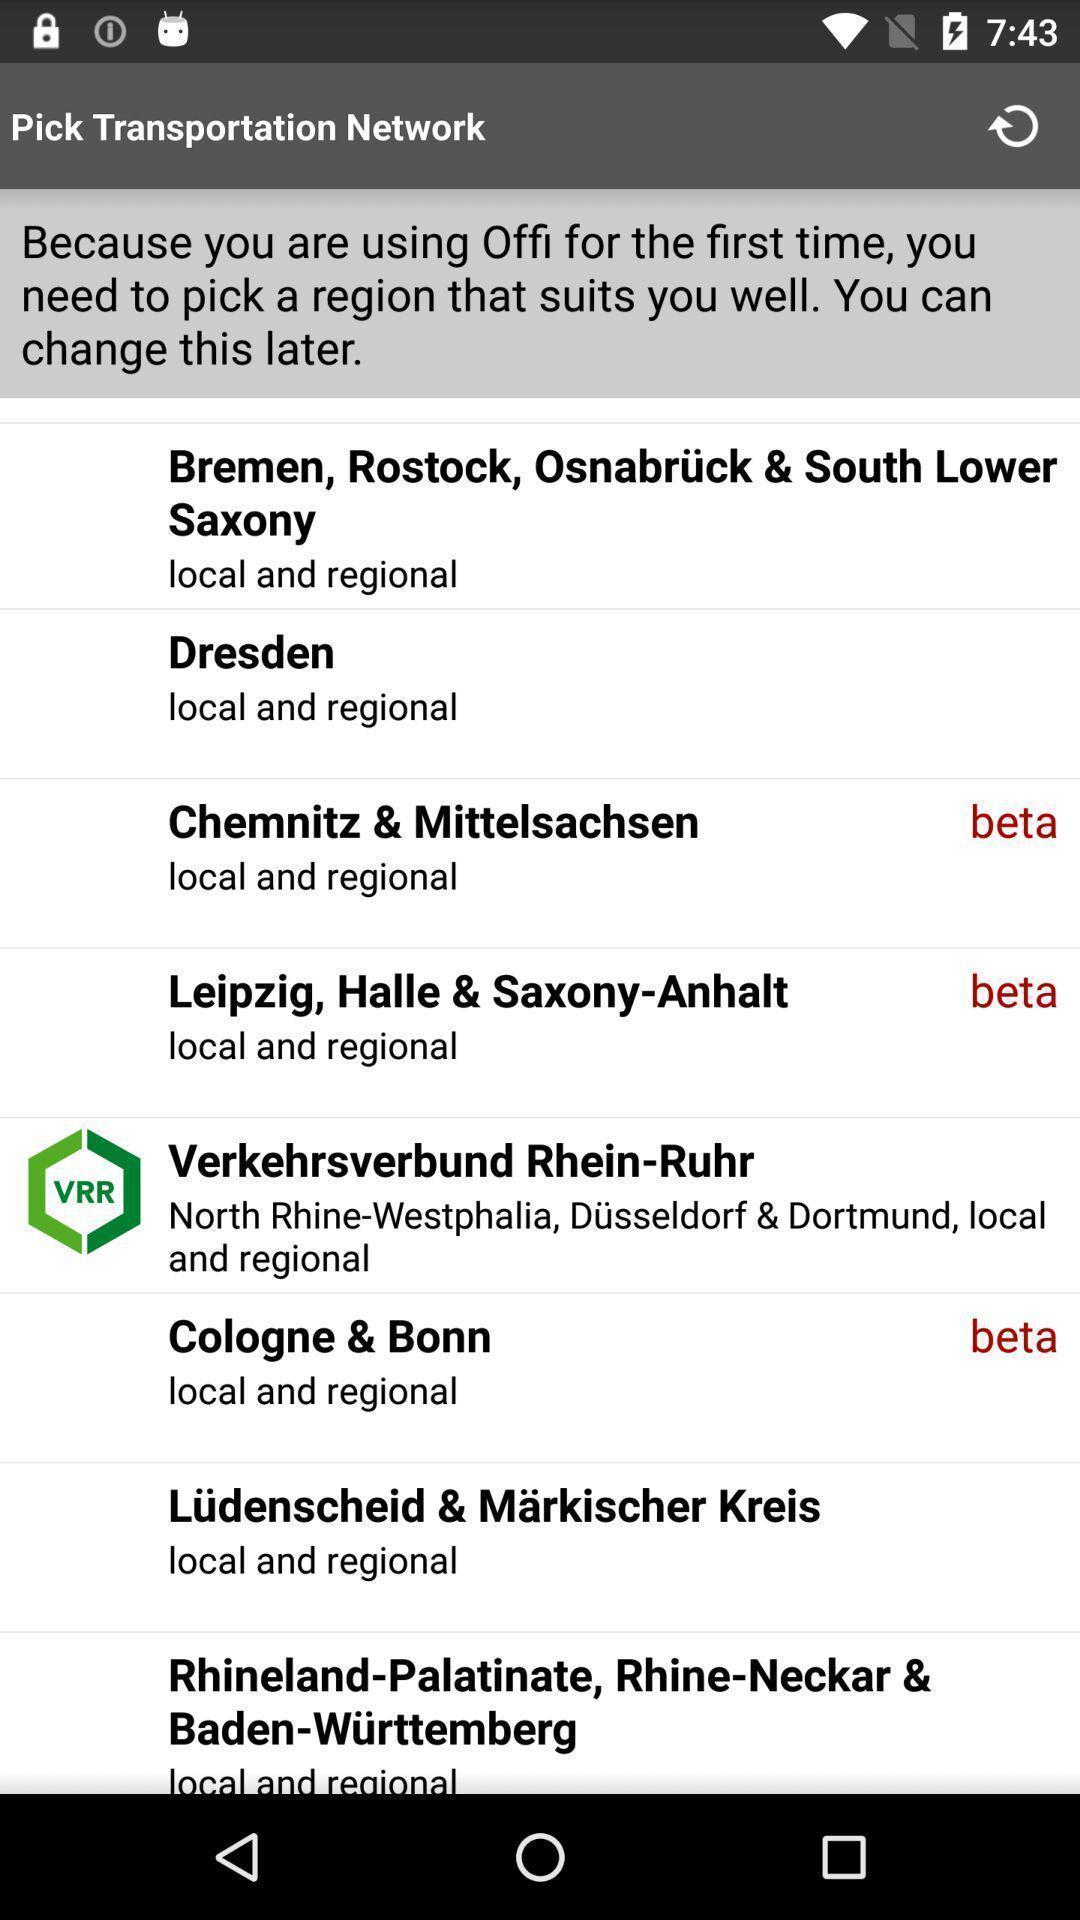Explain what's happening in this screen capture. Page displaying options to pick a region. 